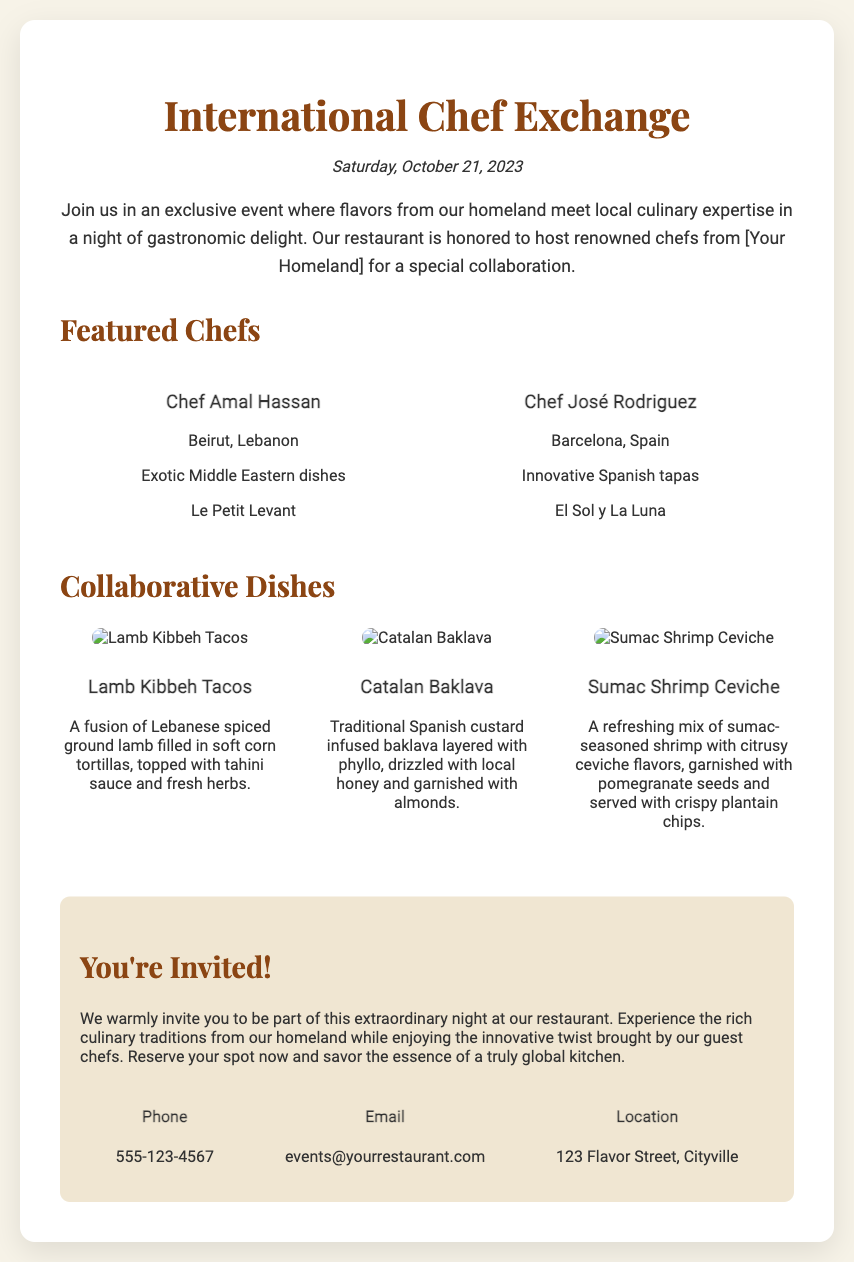What is the date of the event? The date of the event is stated clearly at the top of the document, which is Saturday, October 21, 2023.
Answer: Saturday, October 21, 2023 Who are the featured chefs? The document lists the names of the chefs and their origins, specifically Chef Amal Hassan and Chef José Rodriguez.
Answer: Chef Amal Hassan and Chef José Rodriguez What dish features lamb? The document describes several collaborative dishes, and the one featuring lamb is specifically named Lamb Kibbeh Tacos.
Answer: Lamb Kibbeh Tacos What type of cuisine does Chef José Rodriguez specialize in? The document mentions that Chef José Rodriguez specializes in innovative Spanish tapas.
Answer: Innovative Spanish tapas How many collaborative dishes are showcased? The document lists three collaborative dishes, each described with images and details.
Answer: Three What is the location of the restaurant? The restaurant's address is provided in the invitation section, which specifies the location as 123 Flavor Street, Cityville.
Answer: 123 Flavor Street, Cityville What is the main theme of the event? The introductory paragraph outlines that the main theme is a fusion of flavors from the homeland and local culinary expertise.
Answer: Gastronomic delight What is the contact phone number for reservations? A specific phone number for contacting the restaurant is given in the contact section, which is 555-123-4567.
Answer: 555-123-4567 